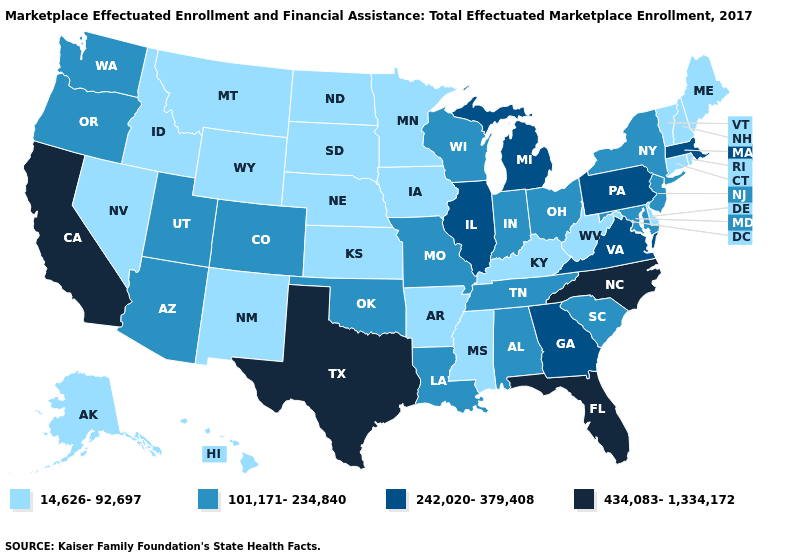Does New Mexico have the highest value in the West?
Short answer required. No. Is the legend a continuous bar?
Give a very brief answer. No. What is the value of Wisconsin?
Quick response, please. 101,171-234,840. Does Georgia have a higher value than California?
Be succinct. No. Name the states that have a value in the range 14,626-92,697?
Short answer required. Alaska, Arkansas, Connecticut, Delaware, Hawaii, Idaho, Iowa, Kansas, Kentucky, Maine, Minnesota, Mississippi, Montana, Nebraska, Nevada, New Hampshire, New Mexico, North Dakota, Rhode Island, South Dakota, Vermont, West Virginia, Wyoming. Among the states that border Georgia , does Tennessee have the lowest value?
Be succinct. Yes. What is the lowest value in states that border Rhode Island?
Concise answer only. 14,626-92,697. What is the value of Vermont?
Quick response, please. 14,626-92,697. Does Maryland have a lower value than Illinois?
Concise answer only. Yes. What is the value of Texas?
Give a very brief answer. 434,083-1,334,172. Which states have the lowest value in the West?
Quick response, please. Alaska, Hawaii, Idaho, Montana, Nevada, New Mexico, Wyoming. Which states have the lowest value in the USA?
Short answer required. Alaska, Arkansas, Connecticut, Delaware, Hawaii, Idaho, Iowa, Kansas, Kentucky, Maine, Minnesota, Mississippi, Montana, Nebraska, Nevada, New Hampshire, New Mexico, North Dakota, Rhode Island, South Dakota, Vermont, West Virginia, Wyoming. Among the states that border Massachusetts , does New York have the highest value?
Write a very short answer. Yes. Which states have the highest value in the USA?
Give a very brief answer. California, Florida, North Carolina, Texas. 